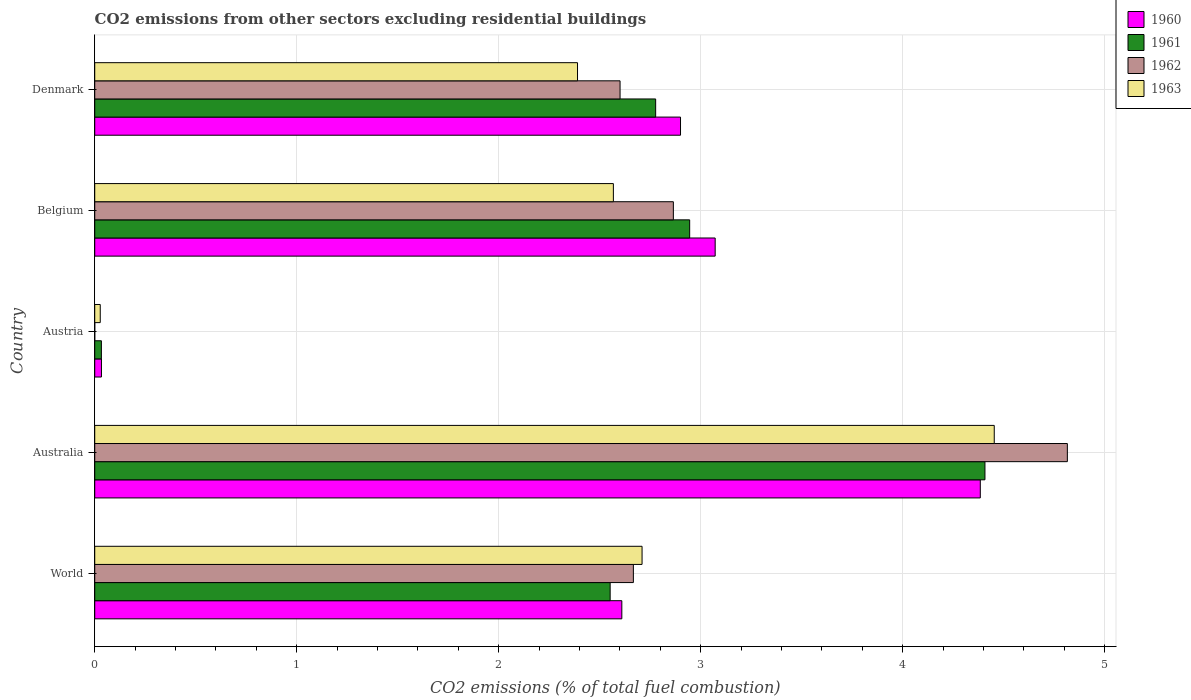How many different coloured bars are there?
Offer a very short reply. 4. How many groups of bars are there?
Your answer should be very brief. 5. Are the number of bars on each tick of the Y-axis equal?
Provide a succinct answer. No. What is the label of the 5th group of bars from the top?
Give a very brief answer. World. In how many cases, is the number of bars for a given country not equal to the number of legend labels?
Your answer should be compact. 1. What is the total CO2 emitted in 1962 in Denmark?
Your answer should be compact. 2.6. Across all countries, what is the maximum total CO2 emitted in 1963?
Make the answer very short. 4.45. Across all countries, what is the minimum total CO2 emitted in 1960?
Offer a very short reply. 0.03. What is the total total CO2 emitted in 1960 in the graph?
Offer a very short reply. 13. What is the difference between the total CO2 emitted in 1962 in Australia and that in Belgium?
Provide a succinct answer. 1.95. What is the difference between the total CO2 emitted in 1963 in Austria and the total CO2 emitted in 1960 in Denmark?
Make the answer very short. -2.87. What is the average total CO2 emitted in 1961 per country?
Ensure brevity in your answer.  2.54. What is the difference between the total CO2 emitted in 1961 and total CO2 emitted in 1963 in Austria?
Provide a succinct answer. 0.01. What is the ratio of the total CO2 emitted in 1963 in Belgium to that in Denmark?
Provide a succinct answer. 1.07. Is the total CO2 emitted in 1960 in Denmark less than that in World?
Your answer should be compact. No. Is the difference between the total CO2 emitted in 1961 in Australia and Austria greater than the difference between the total CO2 emitted in 1963 in Australia and Austria?
Keep it short and to the point. No. What is the difference between the highest and the second highest total CO2 emitted in 1961?
Your answer should be compact. 1.46. What is the difference between the highest and the lowest total CO2 emitted in 1961?
Offer a terse response. 4.37. How many bars are there?
Your response must be concise. 19. Are all the bars in the graph horizontal?
Offer a terse response. Yes. Are the values on the major ticks of X-axis written in scientific E-notation?
Your answer should be very brief. No. How many legend labels are there?
Your answer should be very brief. 4. What is the title of the graph?
Your answer should be very brief. CO2 emissions from other sectors excluding residential buildings. Does "1994" appear as one of the legend labels in the graph?
Your answer should be very brief. No. What is the label or title of the X-axis?
Give a very brief answer. CO2 emissions (% of total fuel combustion). What is the CO2 emissions (% of total fuel combustion) in 1960 in World?
Your answer should be very brief. 2.61. What is the CO2 emissions (% of total fuel combustion) in 1961 in World?
Ensure brevity in your answer.  2.55. What is the CO2 emissions (% of total fuel combustion) in 1962 in World?
Keep it short and to the point. 2.67. What is the CO2 emissions (% of total fuel combustion) of 1963 in World?
Provide a short and direct response. 2.71. What is the CO2 emissions (% of total fuel combustion) in 1960 in Australia?
Provide a short and direct response. 4.38. What is the CO2 emissions (% of total fuel combustion) in 1961 in Australia?
Give a very brief answer. 4.41. What is the CO2 emissions (% of total fuel combustion) of 1962 in Australia?
Keep it short and to the point. 4.82. What is the CO2 emissions (% of total fuel combustion) in 1963 in Australia?
Give a very brief answer. 4.45. What is the CO2 emissions (% of total fuel combustion) of 1960 in Austria?
Make the answer very short. 0.03. What is the CO2 emissions (% of total fuel combustion) in 1961 in Austria?
Make the answer very short. 0.03. What is the CO2 emissions (% of total fuel combustion) in 1962 in Austria?
Your response must be concise. 0. What is the CO2 emissions (% of total fuel combustion) of 1963 in Austria?
Give a very brief answer. 0.03. What is the CO2 emissions (% of total fuel combustion) in 1960 in Belgium?
Give a very brief answer. 3.07. What is the CO2 emissions (% of total fuel combustion) in 1961 in Belgium?
Give a very brief answer. 2.95. What is the CO2 emissions (% of total fuel combustion) of 1962 in Belgium?
Keep it short and to the point. 2.86. What is the CO2 emissions (% of total fuel combustion) in 1963 in Belgium?
Make the answer very short. 2.57. What is the CO2 emissions (% of total fuel combustion) of 1960 in Denmark?
Give a very brief answer. 2.9. What is the CO2 emissions (% of total fuel combustion) in 1961 in Denmark?
Provide a short and direct response. 2.78. What is the CO2 emissions (% of total fuel combustion) in 1962 in Denmark?
Give a very brief answer. 2.6. What is the CO2 emissions (% of total fuel combustion) in 1963 in Denmark?
Ensure brevity in your answer.  2.39. Across all countries, what is the maximum CO2 emissions (% of total fuel combustion) in 1960?
Give a very brief answer. 4.38. Across all countries, what is the maximum CO2 emissions (% of total fuel combustion) in 1961?
Provide a short and direct response. 4.41. Across all countries, what is the maximum CO2 emissions (% of total fuel combustion) in 1962?
Keep it short and to the point. 4.82. Across all countries, what is the maximum CO2 emissions (% of total fuel combustion) in 1963?
Give a very brief answer. 4.45. Across all countries, what is the minimum CO2 emissions (% of total fuel combustion) in 1960?
Provide a succinct answer. 0.03. Across all countries, what is the minimum CO2 emissions (% of total fuel combustion) of 1961?
Your response must be concise. 0.03. Across all countries, what is the minimum CO2 emissions (% of total fuel combustion) in 1963?
Provide a succinct answer. 0.03. What is the total CO2 emissions (% of total fuel combustion) of 1960 in the graph?
Your answer should be compact. 13. What is the total CO2 emissions (% of total fuel combustion) of 1961 in the graph?
Make the answer very short. 12.71. What is the total CO2 emissions (% of total fuel combustion) of 1962 in the graph?
Give a very brief answer. 12.95. What is the total CO2 emissions (% of total fuel combustion) of 1963 in the graph?
Offer a terse response. 12.15. What is the difference between the CO2 emissions (% of total fuel combustion) of 1960 in World and that in Australia?
Keep it short and to the point. -1.77. What is the difference between the CO2 emissions (% of total fuel combustion) of 1961 in World and that in Australia?
Offer a terse response. -1.86. What is the difference between the CO2 emissions (% of total fuel combustion) in 1962 in World and that in Australia?
Your response must be concise. -2.15. What is the difference between the CO2 emissions (% of total fuel combustion) of 1963 in World and that in Australia?
Provide a succinct answer. -1.74. What is the difference between the CO2 emissions (% of total fuel combustion) in 1960 in World and that in Austria?
Your answer should be compact. 2.58. What is the difference between the CO2 emissions (% of total fuel combustion) of 1961 in World and that in Austria?
Your response must be concise. 2.52. What is the difference between the CO2 emissions (% of total fuel combustion) of 1963 in World and that in Austria?
Provide a short and direct response. 2.68. What is the difference between the CO2 emissions (% of total fuel combustion) of 1960 in World and that in Belgium?
Make the answer very short. -0.46. What is the difference between the CO2 emissions (% of total fuel combustion) in 1961 in World and that in Belgium?
Your answer should be very brief. -0.39. What is the difference between the CO2 emissions (% of total fuel combustion) in 1962 in World and that in Belgium?
Your response must be concise. -0.2. What is the difference between the CO2 emissions (% of total fuel combustion) in 1963 in World and that in Belgium?
Offer a terse response. 0.14. What is the difference between the CO2 emissions (% of total fuel combustion) in 1960 in World and that in Denmark?
Offer a terse response. -0.29. What is the difference between the CO2 emissions (% of total fuel combustion) in 1961 in World and that in Denmark?
Give a very brief answer. -0.23. What is the difference between the CO2 emissions (% of total fuel combustion) in 1962 in World and that in Denmark?
Keep it short and to the point. 0.07. What is the difference between the CO2 emissions (% of total fuel combustion) of 1963 in World and that in Denmark?
Make the answer very short. 0.32. What is the difference between the CO2 emissions (% of total fuel combustion) of 1960 in Australia and that in Austria?
Ensure brevity in your answer.  4.35. What is the difference between the CO2 emissions (% of total fuel combustion) of 1961 in Australia and that in Austria?
Your response must be concise. 4.37. What is the difference between the CO2 emissions (% of total fuel combustion) in 1963 in Australia and that in Austria?
Provide a short and direct response. 4.43. What is the difference between the CO2 emissions (% of total fuel combustion) in 1960 in Australia and that in Belgium?
Keep it short and to the point. 1.31. What is the difference between the CO2 emissions (% of total fuel combustion) of 1961 in Australia and that in Belgium?
Your answer should be very brief. 1.46. What is the difference between the CO2 emissions (% of total fuel combustion) in 1962 in Australia and that in Belgium?
Make the answer very short. 1.95. What is the difference between the CO2 emissions (% of total fuel combustion) in 1963 in Australia and that in Belgium?
Provide a succinct answer. 1.89. What is the difference between the CO2 emissions (% of total fuel combustion) of 1960 in Australia and that in Denmark?
Make the answer very short. 1.48. What is the difference between the CO2 emissions (% of total fuel combustion) in 1961 in Australia and that in Denmark?
Give a very brief answer. 1.63. What is the difference between the CO2 emissions (% of total fuel combustion) of 1962 in Australia and that in Denmark?
Give a very brief answer. 2.21. What is the difference between the CO2 emissions (% of total fuel combustion) of 1963 in Australia and that in Denmark?
Your response must be concise. 2.06. What is the difference between the CO2 emissions (% of total fuel combustion) of 1960 in Austria and that in Belgium?
Make the answer very short. -3.04. What is the difference between the CO2 emissions (% of total fuel combustion) of 1961 in Austria and that in Belgium?
Offer a very short reply. -2.91. What is the difference between the CO2 emissions (% of total fuel combustion) in 1963 in Austria and that in Belgium?
Keep it short and to the point. -2.54. What is the difference between the CO2 emissions (% of total fuel combustion) in 1960 in Austria and that in Denmark?
Make the answer very short. -2.87. What is the difference between the CO2 emissions (% of total fuel combustion) of 1961 in Austria and that in Denmark?
Your answer should be compact. -2.74. What is the difference between the CO2 emissions (% of total fuel combustion) in 1963 in Austria and that in Denmark?
Your answer should be very brief. -2.36. What is the difference between the CO2 emissions (% of total fuel combustion) in 1960 in Belgium and that in Denmark?
Ensure brevity in your answer.  0.17. What is the difference between the CO2 emissions (% of total fuel combustion) of 1961 in Belgium and that in Denmark?
Offer a terse response. 0.17. What is the difference between the CO2 emissions (% of total fuel combustion) in 1962 in Belgium and that in Denmark?
Offer a terse response. 0.26. What is the difference between the CO2 emissions (% of total fuel combustion) in 1963 in Belgium and that in Denmark?
Offer a very short reply. 0.18. What is the difference between the CO2 emissions (% of total fuel combustion) in 1960 in World and the CO2 emissions (% of total fuel combustion) in 1961 in Australia?
Keep it short and to the point. -1.8. What is the difference between the CO2 emissions (% of total fuel combustion) in 1960 in World and the CO2 emissions (% of total fuel combustion) in 1962 in Australia?
Your answer should be very brief. -2.21. What is the difference between the CO2 emissions (% of total fuel combustion) in 1960 in World and the CO2 emissions (% of total fuel combustion) in 1963 in Australia?
Provide a short and direct response. -1.84. What is the difference between the CO2 emissions (% of total fuel combustion) of 1961 in World and the CO2 emissions (% of total fuel combustion) of 1962 in Australia?
Your answer should be compact. -2.26. What is the difference between the CO2 emissions (% of total fuel combustion) in 1961 in World and the CO2 emissions (% of total fuel combustion) in 1963 in Australia?
Provide a short and direct response. -1.9. What is the difference between the CO2 emissions (% of total fuel combustion) in 1962 in World and the CO2 emissions (% of total fuel combustion) in 1963 in Australia?
Your answer should be very brief. -1.79. What is the difference between the CO2 emissions (% of total fuel combustion) of 1960 in World and the CO2 emissions (% of total fuel combustion) of 1961 in Austria?
Your answer should be compact. 2.58. What is the difference between the CO2 emissions (% of total fuel combustion) of 1960 in World and the CO2 emissions (% of total fuel combustion) of 1963 in Austria?
Your answer should be compact. 2.58. What is the difference between the CO2 emissions (% of total fuel combustion) in 1961 in World and the CO2 emissions (% of total fuel combustion) in 1963 in Austria?
Offer a terse response. 2.52. What is the difference between the CO2 emissions (% of total fuel combustion) of 1962 in World and the CO2 emissions (% of total fuel combustion) of 1963 in Austria?
Give a very brief answer. 2.64. What is the difference between the CO2 emissions (% of total fuel combustion) in 1960 in World and the CO2 emissions (% of total fuel combustion) in 1961 in Belgium?
Your response must be concise. -0.34. What is the difference between the CO2 emissions (% of total fuel combustion) of 1960 in World and the CO2 emissions (% of total fuel combustion) of 1962 in Belgium?
Offer a terse response. -0.26. What is the difference between the CO2 emissions (% of total fuel combustion) in 1960 in World and the CO2 emissions (% of total fuel combustion) in 1963 in Belgium?
Provide a short and direct response. 0.04. What is the difference between the CO2 emissions (% of total fuel combustion) in 1961 in World and the CO2 emissions (% of total fuel combustion) in 1962 in Belgium?
Provide a short and direct response. -0.31. What is the difference between the CO2 emissions (% of total fuel combustion) in 1961 in World and the CO2 emissions (% of total fuel combustion) in 1963 in Belgium?
Give a very brief answer. -0.02. What is the difference between the CO2 emissions (% of total fuel combustion) in 1962 in World and the CO2 emissions (% of total fuel combustion) in 1963 in Belgium?
Ensure brevity in your answer.  0.1. What is the difference between the CO2 emissions (% of total fuel combustion) in 1960 in World and the CO2 emissions (% of total fuel combustion) in 1961 in Denmark?
Keep it short and to the point. -0.17. What is the difference between the CO2 emissions (% of total fuel combustion) in 1960 in World and the CO2 emissions (% of total fuel combustion) in 1962 in Denmark?
Your response must be concise. 0.01. What is the difference between the CO2 emissions (% of total fuel combustion) in 1960 in World and the CO2 emissions (% of total fuel combustion) in 1963 in Denmark?
Provide a succinct answer. 0.22. What is the difference between the CO2 emissions (% of total fuel combustion) of 1961 in World and the CO2 emissions (% of total fuel combustion) of 1962 in Denmark?
Your answer should be compact. -0.05. What is the difference between the CO2 emissions (% of total fuel combustion) of 1961 in World and the CO2 emissions (% of total fuel combustion) of 1963 in Denmark?
Provide a succinct answer. 0.16. What is the difference between the CO2 emissions (% of total fuel combustion) in 1962 in World and the CO2 emissions (% of total fuel combustion) in 1963 in Denmark?
Ensure brevity in your answer.  0.28. What is the difference between the CO2 emissions (% of total fuel combustion) in 1960 in Australia and the CO2 emissions (% of total fuel combustion) in 1961 in Austria?
Keep it short and to the point. 4.35. What is the difference between the CO2 emissions (% of total fuel combustion) of 1960 in Australia and the CO2 emissions (% of total fuel combustion) of 1963 in Austria?
Ensure brevity in your answer.  4.36. What is the difference between the CO2 emissions (% of total fuel combustion) in 1961 in Australia and the CO2 emissions (% of total fuel combustion) in 1963 in Austria?
Your response must be concise. 4.38. What is the difference between the CO2 emissions (% of total fuel combustion) of 1962 in Australia and the CO2 emissions (% of total fuel combustion) of 1963 in Austria?
Keep it short and to the point. 4.79. What is the difference between the CO2 emissions (% of total fuel combustion) of 1960 in Australia and the CO2 emissions (% of total fuel combustion) of 1961 in Belgium?
Keep it short and to the point. 1.44. What is the difference between the CO2 emissions (% of total fuel combustion) in 1960 in Australia and the CO2 emissions (% of total fuel combustion) in 1962 in Belgium?
Offer a very short reply. 1.52. What is the difference between the CO2 emissions (% of total fuel combustion) in 1960 in Australia and the CO2 emissions (% of total fuel combustion) in 1963 in Belgium?
Ensure brevity in your answer.  1.82. What is the difference between the CO2 emissions (% of total fuel combustion) in 1961 in Australia and the CO2 emissions (% of total fuel combustion) in 1962 in Belgium?
Provide a succinct answer. 1.54. What is the difference between the CO2 emissions (% of total fuel combustion) in 1961 in Australia and the CO2 emissions (% of total fuel combustion) in 1963 in Belgium?
Provide a short and direct response. 1.84. What is the difference between the CO2 emissions (% of total fuel combustion) in 1962 in Australia and the CO2 emissions (% of total fuel combustion) in 1963 in Belgium?
Make the answer very short. 2.25. What is the difference between the CO2 emissions (% of total fuel combustion) in 1960 in Australia and the CO2 emissions (% of total fuel combustion) in 1961 in Denmark?
Provide a succinct answer. 1.61. What is the difference between the CO2 emissions (% of total fuel combustion) of 1960 in Australia and the CO2 emissions (% of total fuel combustion) of 1962 in Denmark?
Offer a very short reply. 1.78. What is the difference between the CO2 emissions (% of total fuel combustion) of 1960 in Australia and the CO2 emissions (% of total fuel combustion) of 1963 in Denmark?
Ensure brevity in your answer.  1.99. What is the difference between the CO2 emissions (% of total fuel combustion) of 1961 in Australia and the CO2 emissions (% of total fuel combustion) of 1962 in Denmark?
Ensure brevity in your answer.  1.81. What is the difference between the CO2 emissions (% of total fuel combustion) of 1961 in Australia and the CO2 emissions (% of total fuel combustion) of 1963 in Denmark?
Offer a very short reply. 2.02. What is the difference between the CO2 emissions (% of total fuel combustion) in 1962 in Australia and the CO2 emissions (% of total fuel combustion) in 1963 in Denmark?
Make the answer very short. 2.42. What is the difference between the CO2 emissions (% of total fuel combustion) of 1960 in Austria and the CO2 emissions (% of total fuel combustion) of 1961 in Belgium?
Ensure brevity in your answer.  -2.91. What is the difference between the CO2 emissions (% of total fuel combustion) in 1960 in Austria and the CO2 emissions (% of total fuel combustion) in 1962 in Belgium?
Provide a succinct answer. -2.83. What is the difference between the CO2 emissions (% of total fuel combustion) of 1960 in Austria and the CO2 emissions (% of total fuel combustion) of 1963 in Belgium?
Your answer should be very brief. -2.53. What is the difference between the CO2 emissions (% of total fuel combustion) of 1961 in Austria and the CO2 emissions (% of total fuel combustion) of 1962 in Belgium?
Offer a terse response. -2.83. What is the difference between the CO2 emissions (% of total fuel combustion) of 1961 in Austria and the CO2 emissions (% of total fuel combustion) of 1963 in Belgium?
Provide a succinct answer. -2.53. What is the difference between the CO2 emissions (% of total fuel combustion) in 1960 in Austria and the CO2 emissions (% of total fuel combustion) in 1961 in Denmark?
Provide a succinct answer. -2.74. What is the difference between the CO2 emissions (% of total fuel combustion) of 1960 in Austria and the CO2 emissions (% of total fuel combustion) of 1962 in Denmark?
Offer a terse response. -2.57. What is the difference between the CO2 emissions (% of total fuel combustion) of 1960 in Austria and the CO2 emissions (% of total fuel combustion) of 1963 in Denmark?
Your response must be concise. -2.36. What is the difference between the CO2 emissions (% of total fuel combustion) of 1961 in Austria and the CO2 emissions (% of total fuel combustion) of 1962 in Denmark?
Your response must be concise. -2.57. What is the difference between the CO2 emissions (% of total fuel combustion) in 1961 in Austria and the CO2 emissions (% of total fuel combustion) in 1963 in Denmark?
Provide a succinct answer. -2.36. What is the difference between the CO2 emissions (% of total fuel combustion) of 1960 in Belgium and the CO2 emissions (% of total fuel combustion) of 1961 in Denmark?
Offer a terse response. 0.29. What is the difference between the CO2 emissions (% of total fuel combustion) in 1960 in Belgium and the CO2 emissions (% of total fuel combustion) in 1962 in Denmark?
Keep it short and to the point. 0.47. What is the difference between the CO2 emissions (% of total fuel combustion) in 1960 in Belgium and the CO2 emissions (% of total fuel combustion) in 1963 in Denmark?
Provide a short and direct response. 0.68. What is the difference between the CO2 emissions (% of total fuel combustion) of 1961 in Belgium and the CO2 emissions (% of total fuel combustion) of 1962 in Denmark?
Make the answer very short. 0.34. What is the difference between the CO2 emissions (% of total fuel combustion) in 1961 in Belgium and the CO2 emissions (% of total fuel combustion) in 1963 in Denmark?
Offer a very short reply. 0.56. What is the difference between the CO2 emissions (% of total fuel combustion) in 1962 in Belgium and the CO2 emissions (% of total fuel combustion) in 1963 in Denmark?
Keep it short and to the point. 0.47. What is the average CO2 emissions (% of total fuel combustion) in 1960 per country?
Make the answer very short. 2.6. What is the average CO2 emissions (% of total fuel combustion) in 1961 per country?
Your response must be concise. 2.54. What is the average CO2 emissions (% of total fuel combustion) in 1962 per country?
Provide a succinct answer. 2.59. What is the average CO2 emissions (% of total fuel combustion) in 1963 per country?
Give a very brief answer. 2.43. What is the difference between the CO2 emissions (% of total fuel combustion) in 1960 and CO2 emissions (% of total fuel combustion) in 1961 in World?
Your answer should be very brief. 0.06. What is the difference between the CO2 emissions (% of total fuel combustion) in 1960 and CO2 emissions (% of total fuel combustion) in 1962 in World?
Give a very brief answer. -0.06. What is the difference between the CO2 emissions (% of total fuel combustion) in 1960 and CO2 emissions (% of total fuel combustion) in 1963 in World?
Make the answer very short. -0.1. What is the difference between the CO2 emissions (% of total fuel combustion) of 1961 and CO2 emissions (% of total fuel combustion) of 1962 in World?
Provide a short and direct response. -0.12. What is the difference between the CO2 emissions (% of total fuel combustion) of 1961 and CO2 emissions (% of total fuel combustion) of 1963 in World?
Make the answer very short. -0.16. What is the difference between the CO2 emissions (% of total fuel combustion) of 1962 and CO2 emissions (% of total fuel combustion) of 1963 in World?
Keep it short and to the point. -0.04. What is the difference between the CO2 emissions (% of total fuel combustion) in 1960 and CO2 emissions (% of total fuel combustion) in 1961 in Australia?
Provide a succinct answer. -0.02. What is the difference between the CO2 emissions (% of total fuel combustion) in 1960 and CO2 emissions (% of total fuel combustion) in 1962 in Australia?
Ensure brevity in your answer.  -0.43. What is the difference between the CO2 emissions (% of total fuel combustion) of 1960 and CO2 emissions (% of total fuel combustion) of 1963 in Australia?
Give a very brief answer. -0.07. What is the difference between the CO2 emissions (% of total fuel combustion) in 1961 and CO2 emissions (% of total fuel combustion) in 1962 in Australia?
Give a very brief answer. -0.41. What is the difference between the CO2 emissions (% of total fuel combustion) in 1961 and CO2 emissions (% of total fuel combustion) in 1963 in Australia?
Your answer should be compact. -0.05. What is the difference between the CO2 emissions (% of total fuel combustion) of 1962 and CO2 emissions (% of total fuel combustion) of 1963 in Australia?
Make the answer very short. 0.36. What is the difference between the CO2 emissions (% of total fuel combustion) in 1960 and CO2 emissions (% of total fuel combustion) in 1963 in Austria?
Keep it short and to the point. 0.01. What is the difference between the CO2 emissions (% of total fuel combustion) in 1961 and CO2 emissions (% of total fuel combustion) in 1963 in Austria?
Make the answer very short. 0.01. What is the difference between the CO2 emissions (% of total fuel combustion) of 1960 and CO2 emissions (% of total fuel combustion) of 1961 in Belgium?
Your response must be concise. 0.13. What is the difference between the CO2 emissions (% of total fuel combustion) in 1960 and CO2 emissions (% of total fuel combustion) in 1962 in Belgium?
Your response must be concise. 0.21. What is the difference between the CO2 emissions (% of total fuel combustion) of 1960 and CO2 emissions (% of total fuel combustion) of 1963 in Belgium?
Make the answer very short. 0.5. What is the difference between the CO2 emissions (% of total fuel combustion) in 1961 and CO2 emissions (% of total fuel combustion) in 1962 in Belgium?
Your response must be concise. 0.08. What is the difference between the CO2 emissions (% of total fuel combustion) in 1961 and CO2 emissions (% of total fuel combustion) in 1963 in Belgium?
Keep it short and to the point. 0.38. What is the difference between the CO2 emissions (% of total fuel combustion) of 1962 and CO2 emissions (% of total fuel combustion) of 1963 in Belgium?
Offer a terse response. 0.3. What is the difference between the CO2 emissions (% of total fuel combustion) in 1960 and CO2 emissions (% of total fuel combustion) in 1961 in Denmark?
Ensure brevity in your answer.  0.12. What is the difference between the CO2 emissions (% of total fuel combustion) in 1960 and CO2 emissions (% of total fuel combustion) in 1962 in Denmark?
Make the answer very short. 0.3. What is the difference between the CO2 emissions (% of total fuel combustion) of 1960 and CO2 emissions (% of total fuel combustion) of 1963 in Denmark?
Your answer should be compact. 0.51. What is the difference between the CO2 emissions (% of total fuel combustion) of 1961 and CO2 emissions (% of total fuel combustion) of 1962 in Denmark?
Give a very brief answer. 0.18. What is the difference between the CO2 emissions (% of total fuel combustion) in 1961 and CO2 emissions (% of total fuel combustion) in 1963 in Denmark?
Provide a short and direct response. 0.39. What is the difference between the CO2 emissions (% of total fuel combustion) of 1962 and CO2 emissions (% of total fuel combustion) of 1963 in Denmark?
Ensure brevity in your answer.  0.21. What is the ratio of the CO2 emissions (% of total fuel combustion) in 1960 in World to that in Australia?
Your response must be concise. 0.6. What is the ratio of the CO2 emissions (% of total fuel combustion) of 1961 in World to that in Australia?
Keep it short and to the point. 0.58. What is the ratio of the CO2 emissions (% of total fuel combustion) of 1962 in World to that in Australia?
Give a very brief answer. 0.55. What is the ratio of the CO2 emissions (% of total fuel combustion) of 1963 in World to that in Australia?
Offer a terse response. 0.61. What is the ratio of the CO2 emissions (% of total fuel combustion) of 1960 in World to that in Austria?
Your answer should be compact. 78.47. What is the ratio of the CO2 emissions (% of total fuel combustion) in 1961 in World to that in Austria?
Your response must be concise. 77.37. What is the ratio of the CO2 emissions (% of total fuel combustion) in 1963 in World to that in Austria?
Provide a succinct answer. 99.22. What is the ratio of the CO2 emissions (% of total fuel combustion) in 1960 in World to that in Belgium?
Offer a very short reply. 0.85. What is the ratio of the CO2 emissions (% of total fuel combustion) of 1961 in World to that in Belgium?
Provide a short and direct response. 0.87. What is the ratio of the CO2 emissions (% of total fuel combustion) of 1962 in World to that in Belgium?
Your answer should be compact. 0.93. What is the ratio of the CO2 emissions (% of total fuel combustion) in 1963 in World to that in Belgium?
Your answer should be compact. 1.06. What is the ratio of the CO2 emissions (% of total fuel combustion) in 1960 in World to that in Denmark?
Your answer should be compact. 0.9. What is the ratio of the CO2 emissions (% of total fuel combustion) of 1961 in World to that in Denmark?
Provide a succinct answer. 0.92. What is the ratio of the CO2 emissions (% of total fuel combustion) of 1962 in World to that in Denmark?
Offer a very short reply. 1.03. What is the ratio of the CO2 emissions (% of total fuel combustion) of 1963 in World to that in Denmark?
Make the answer very short. 1.13. What is the ratio of the CO2 emissions (% of total fuel combustion) of 1960 in Australia to that in Austria?
Your answer should be very brief. 131.83. What is the ratio of the CO2 emissions (% of total fuel combustion) in 1961 in Australia to that in Austria?
Your answer should be compact. 133.62. What is the ratio of the CO2 emissions (% of total fuel combustion) in 1963 in Australia to that in Austria?
Give a very brief answer. 163.07. What is the ratio of the CO2 emissions (% of total fuel combustion) of 1960 in Australia to that in Belgium?
Keep it short and to the point. 1.43. What is the ratio of the CO2 emissions (% of total fuel combustion) of 1961 in Australia to that in Belgium?
Offer a very short reply. 1.5. What is the ratio of the CO2 emissions (% of total fuel combustion) in 1962 in Australia to that in Belgium?
Ensure brevity in your answer.  1.68. What is the ratio of the CO2 emissions (% of total fuel combustion) of 1963 in Australia to that in Belgium?
Make the answer very short. 1.73. What is the ratio of the CO2 emissions (% of total fuel combustion) in 1960 in Australia to that in Denmark?
Offer a very short reply. 1.51. What is the ratio of the CO2 emissions (% of total fuel combustion) of 1961 in Australia to that in Denmark?
Your answer should be compact. 1.59. What is the ratio of the CO2 emissions (% of total fuel combustion) of 1962 in Australia to that in Denmark?
Provide a succinct answer. 1.85. What is the ratio of the CO2 emissions (% of total fuel combustion) in 1963 in Australia to that in Denmark?
Your answer should be very brief. 1.86. What is the ratio of the CO2 emissions (% of total fuel combustion) in 1960 in Austria to that in Belgium?
Your response must be concise. 0.01. What is the ratio of the CO2 emissions (% of total fuel combustion) in 1961 in Austria to that in Belgium?
Offer a terse response. 0.01. What is the ratio of the CO2 emissions (% of total fuel combustion) in 1963 in Austria to that in Belgium?
Make the answer very short. 0.01. What is the ratio of the CO2 emissions (% of total fuel combustion) in 1960 in Austria to that in Denmark?
Offer a very short reply. 0.01. What is the ratio of the CO2 emissions (% of total fuel combustion) in 1961 in Austria to that in Denmark?
Offer a terse response. 0.01. What is the ratio of the CO2 emissions (% of total fuel combustion) of 1963 in Austria to that in Denmark?
Your response must be concise. 0.01. What is the ratio of the CO2 emissions (% of total fuel combustion) in 1960 in Belgium to that in Denmark?
Make the answer very short. 1.06. What is the ratio of the CO2 emissions (% of total fuel combustion) of 1961 in Belgium to that in Denmark?
Give a very brief answer. 1.06. What is the ratio of the CO2 emissions (% of total fuel combustion) in 1962 in Belgium to that in Denmark?
Ensure brevity in your answer.  1.1. What is the ratio of the CO2 emissions (% of total fuel combustion) of 1963 in Belgium to that in Denmark?
Your answer should be very brief. 1.07. What is the difference between the highest and the second highest CO2 emissions (% of total fuel combustion) of 1960?
Give a very brief answer. 1.31. What is the difference between the highest and the second highest CO2 emissions (% of total fuel combustion) of 1961?
Your response must be concise. 1.46. What is the difference between the highest and the second highest CO2 emissions (% of total fuel combustion) in 1962?
Your answer should be very brief. 1.95. What is the difference between the highest and the second highest CO2 emissions (% of total fuel combustion) in 1963?
Ensure brevity in your answer.  1.74. What is the difference between the highest and the lowest CO2 emissions (% of total fuel combustion) of 1960?
Provide a succinct answer. 4.35. What is the difference between the highest and the lowest CO2 emissions (% of total fuel combustion) of 1961?
Offer a terse response. 4.37. What is the difference between the highest and the lowest CO2 emissions (% of total fuel combustion) of 1962?
Your response must be concise. 4.82. What is the difference between the highest and the lowest CO2 emissions (% of total fuel combustion) in 1963?
Ensure brevity in your answer.  4.43. 